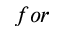<formula> <loc_0><loc_0><loc_500><loc_500>f o r</formula> 